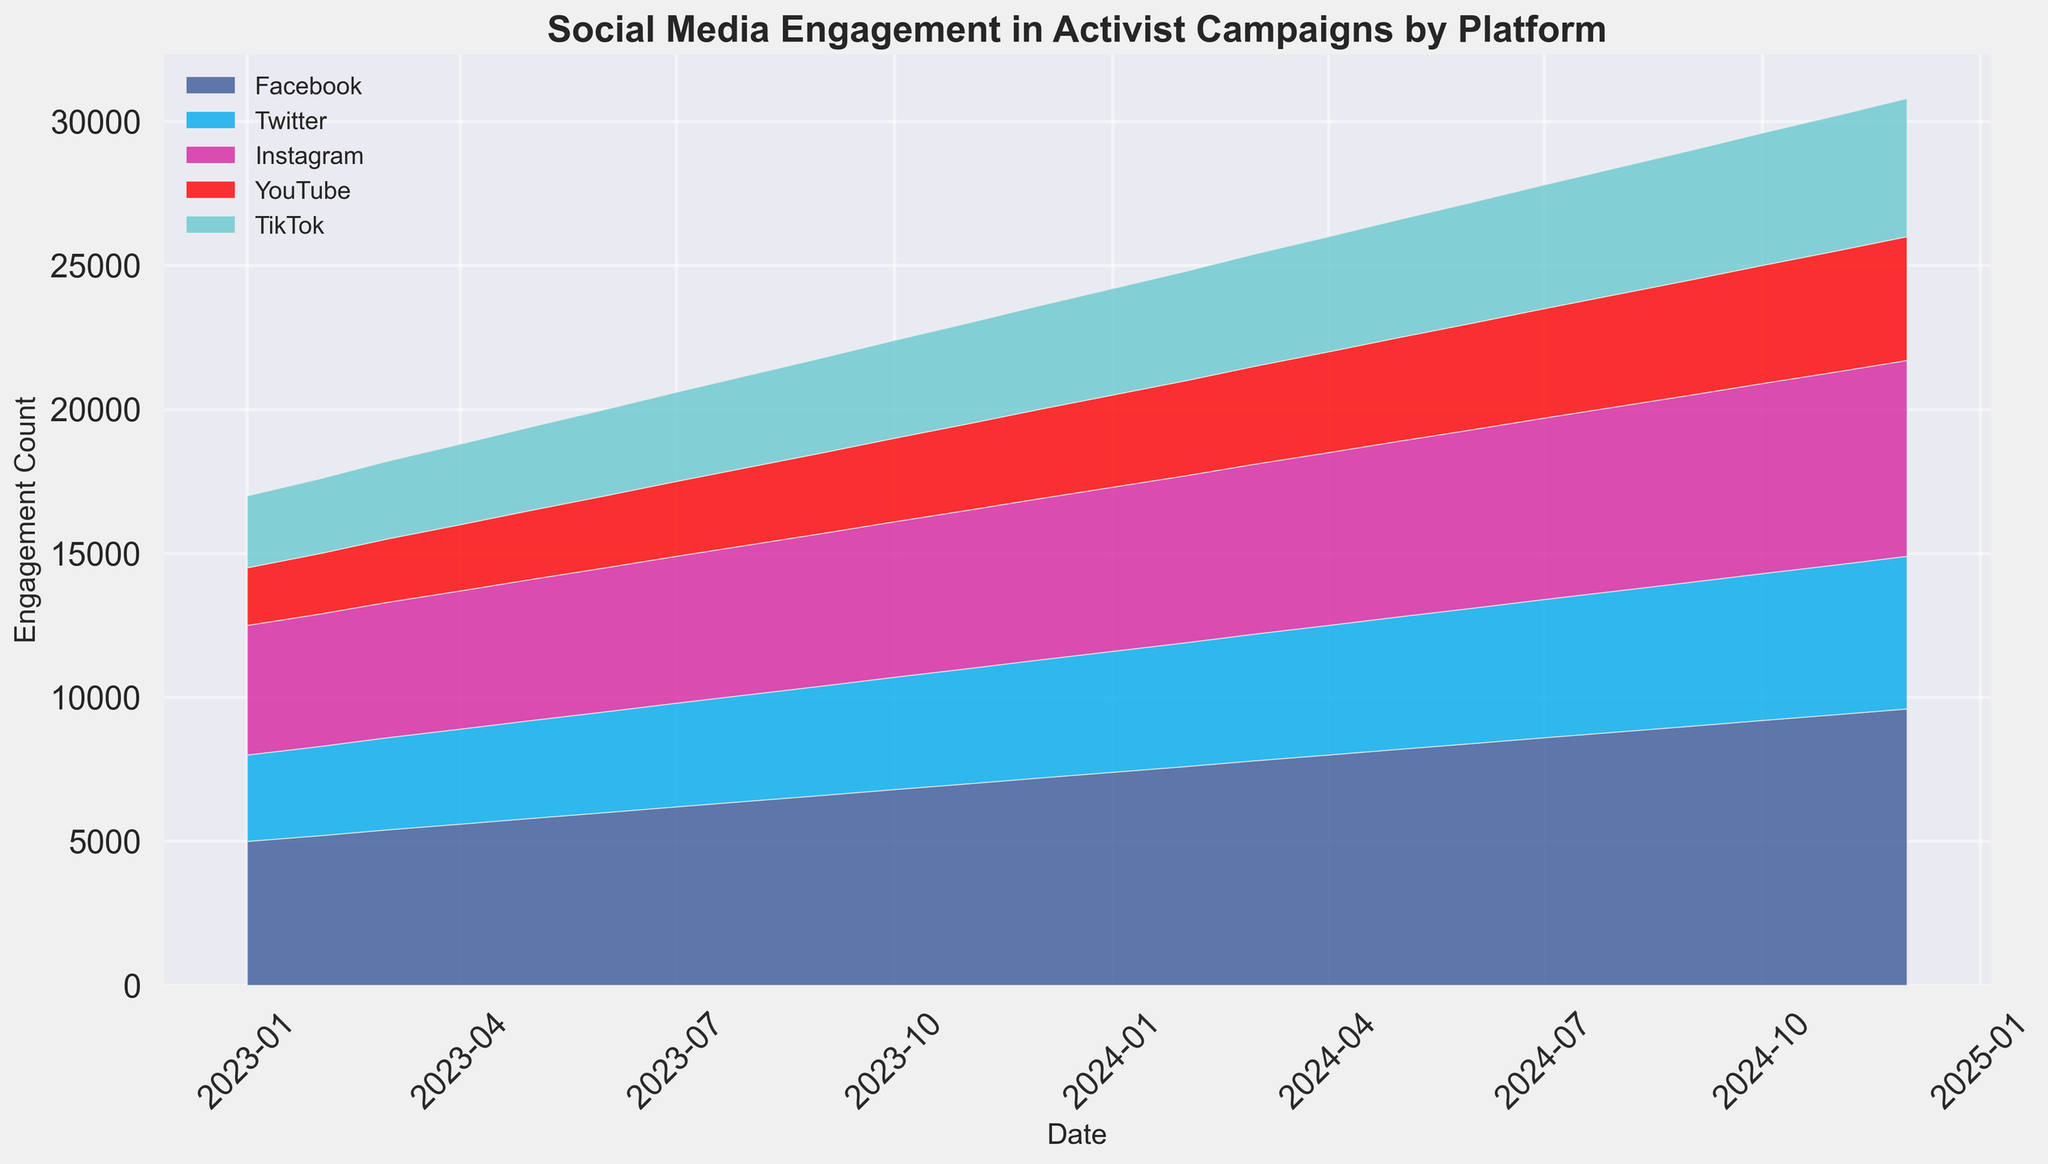what is the total engagement count on social media platforms in January 2023? Add the engagement counts from all platforms for January 2023: Facebook (5000) + Twitter (3000) + Instagram (4500) + YouTube (2000) + TikTok (2500) = 17000
Answer: 17000 Which platform has the highest engagement in December 2024? Look at December 2024 and find the highest engagement value among the platforms: Facebook (9600), Twitter (5300), Instagram (6800), YouTube (4300), and TikTok (4800). Facebook has the highest value.
Answer: Facebook Which platform shows the most consistent growth in engagement from January 2023 to December 2024? Analyze the trends for each platform from January 2023 to December 2024. Facebook shows consistent growth each month without any drop.
Answer: Facebook What is the average engagement count for Instagram over the given period? Sum the engagement counts for Instagram from January 2023 to December 2024 and divide by the total number of months (24): (4500 + 4600 + 4700 + ... + 6800) / 24 = 5550
Answer: 5550 How does TikTok's engagement on July 1, 2023, compare to Instagram's on the same date? Refer to July 1, 2023, and compare TikTok's and Instagram's values: TikTok (3100) and Instagram (5100). TikTok's engagement is lower.
Answer: Lower By how much did Facebook's engagement increase from January 2023 to December 2024? Calculate the difference in Facebook engagement between January 2023 (5000) and December 2024 (9600): 9600 - 5000 = 4600
Answer: 4600 Is there any month where YouTube's engagement exceeds 4000? Check all the values for YouTube to find any that exceed 4000. From September 2024 onward, YouTube has over 4000 engagements.
Answer: Yes By how much did Twitter's engagement increase on average each month? Calculate the average monthly increase for Twitter: (5200 - 3000) / 24 = 91.67
Answer: 91.67 Which month shows the highest combined engagement across all platforms? Calculate the combined engagement for each month and find the highest. December 2024 has the highest: 29500
Answer: December 2024 